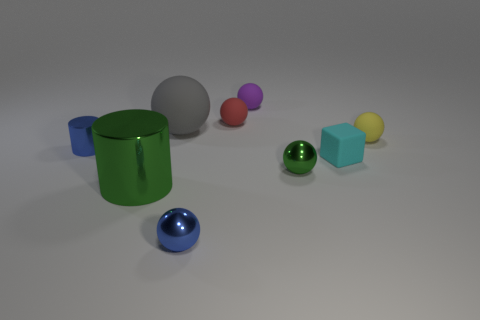Subtract all yellow matte spheres. How many spheres are left? 5 Subtract all gray cubes. Subtract all blue spheres. How many cubes are left? 1 Subtract all cyan cylinders. How many green cubes are left? 0 Subtract all purple spheres. Subtract all gray things. How many objects are left? 7 Add 9 large gray things. How many large gray things are left? 10 Add 3 big green cylinders. How many big green cylinders exist? 4 Add 1 large rubber spheres. How many objects exist? 10 Subtract all yellow spheres. How many spheres are left? 5 Subtract 0 brown cylinders. How many objects are left? 9 Subtract all spheres. How many objects are left? 3 